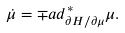Convert formula to latex. <formula><loc_0><loc_0><loc_500><loc_500>\dot { \mu } = \mp a d ^ { * } _ { \partial H / \partial \mu } \mu .</formula> 